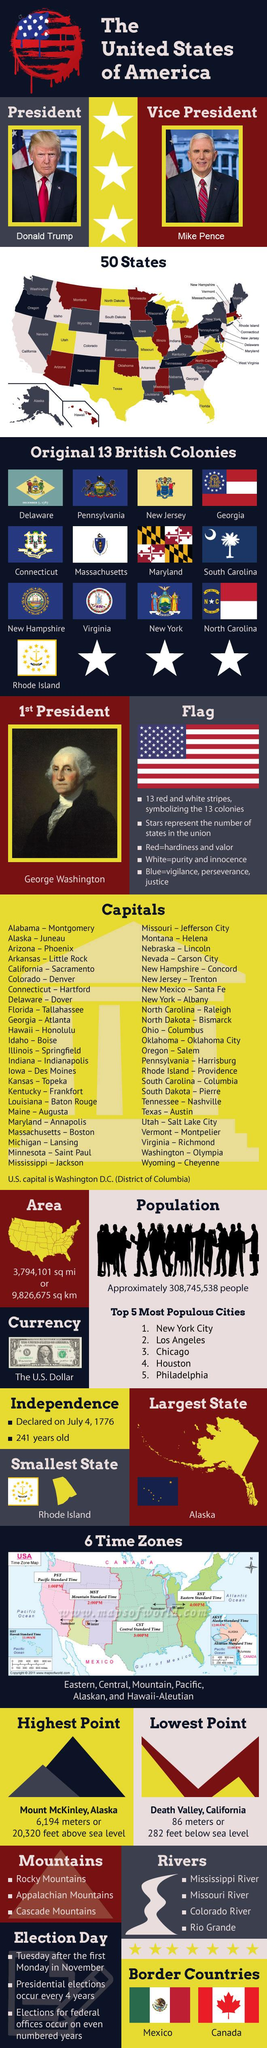Identify some key points in this picture. The lowest point in America is 282 feet below sea level. The U.S. Dollar is the currency of America. The population of America is 308,745,538 people. The Vice President's name is Mike Pence. America's highest point reaches a height of 6,194 meters, or 20,320 feet above sea level. 